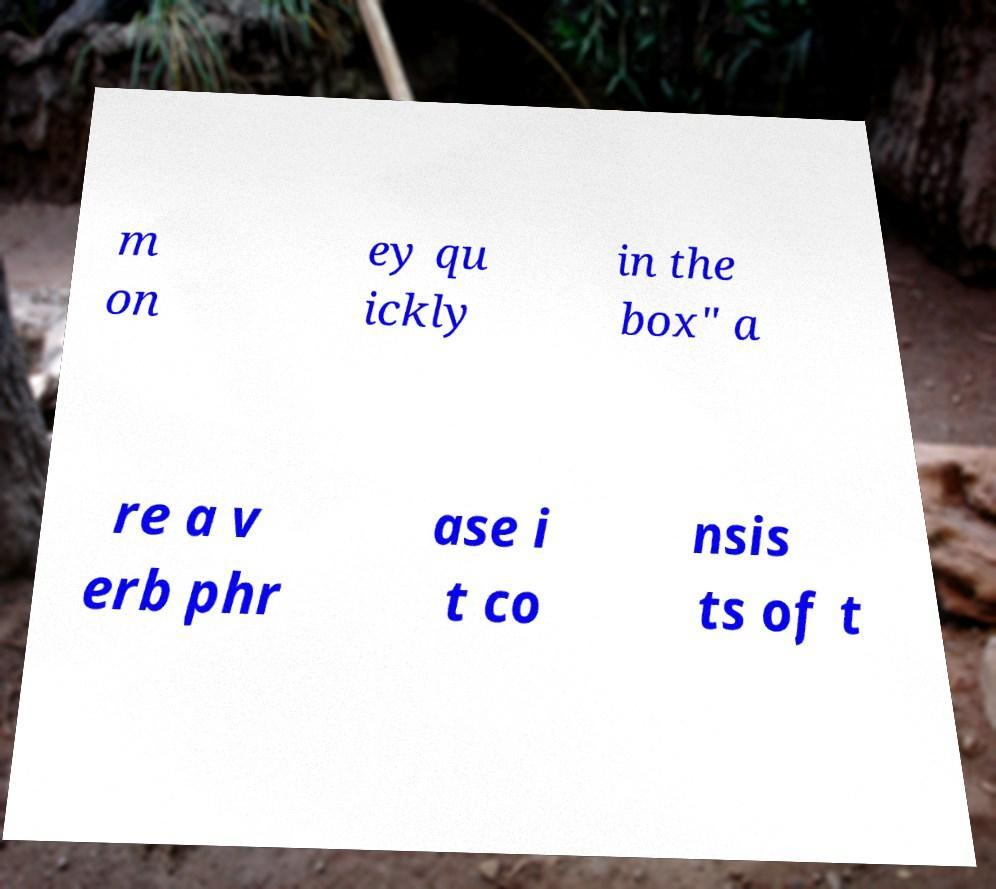Please read and relay the text visible in this image. What does it say? m on ey qu ickly in the box" a re a v erb phr ase i t co nsis ts of t 